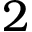Convert formula to latex. <formula><loc_0><loc_0><loc_500><loc_500>2</formula> 